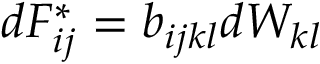Convert formula to latex. <formula><loc_0><loc_0><loc_500><loc_500>\begin{array} { r } { d F _ { i j } ^ { * } = b _ { i j k l } d W _ { k l } } \end{array}</formula> 